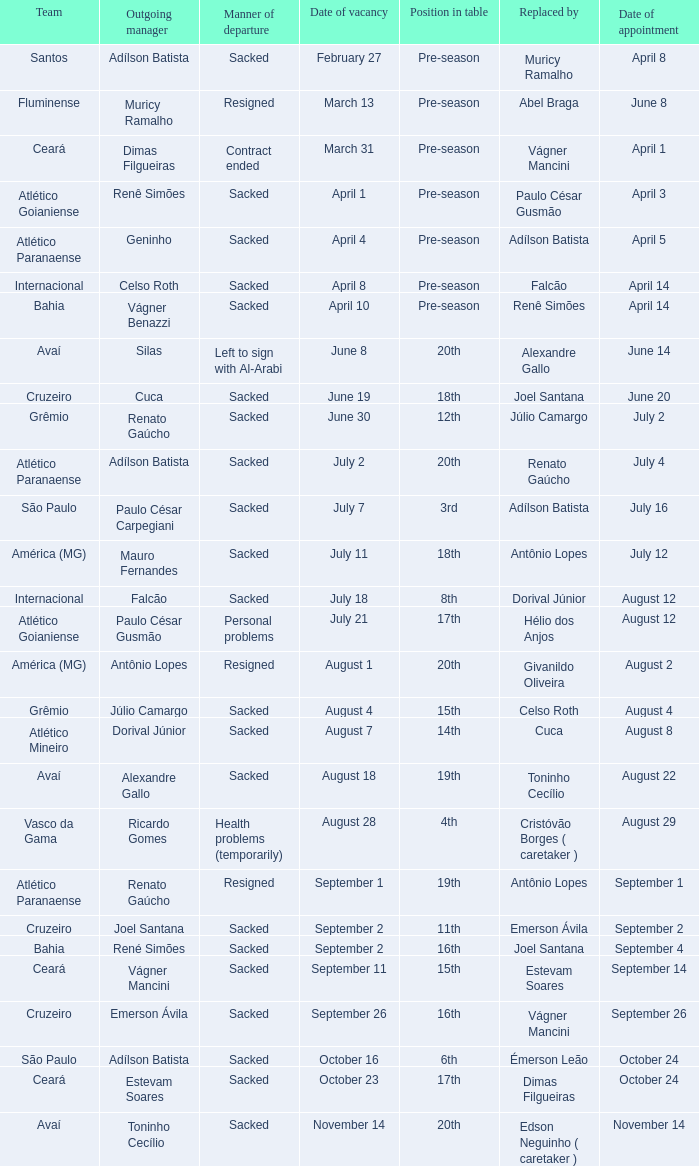Who was replaced as manager on June 20? Cuca. 